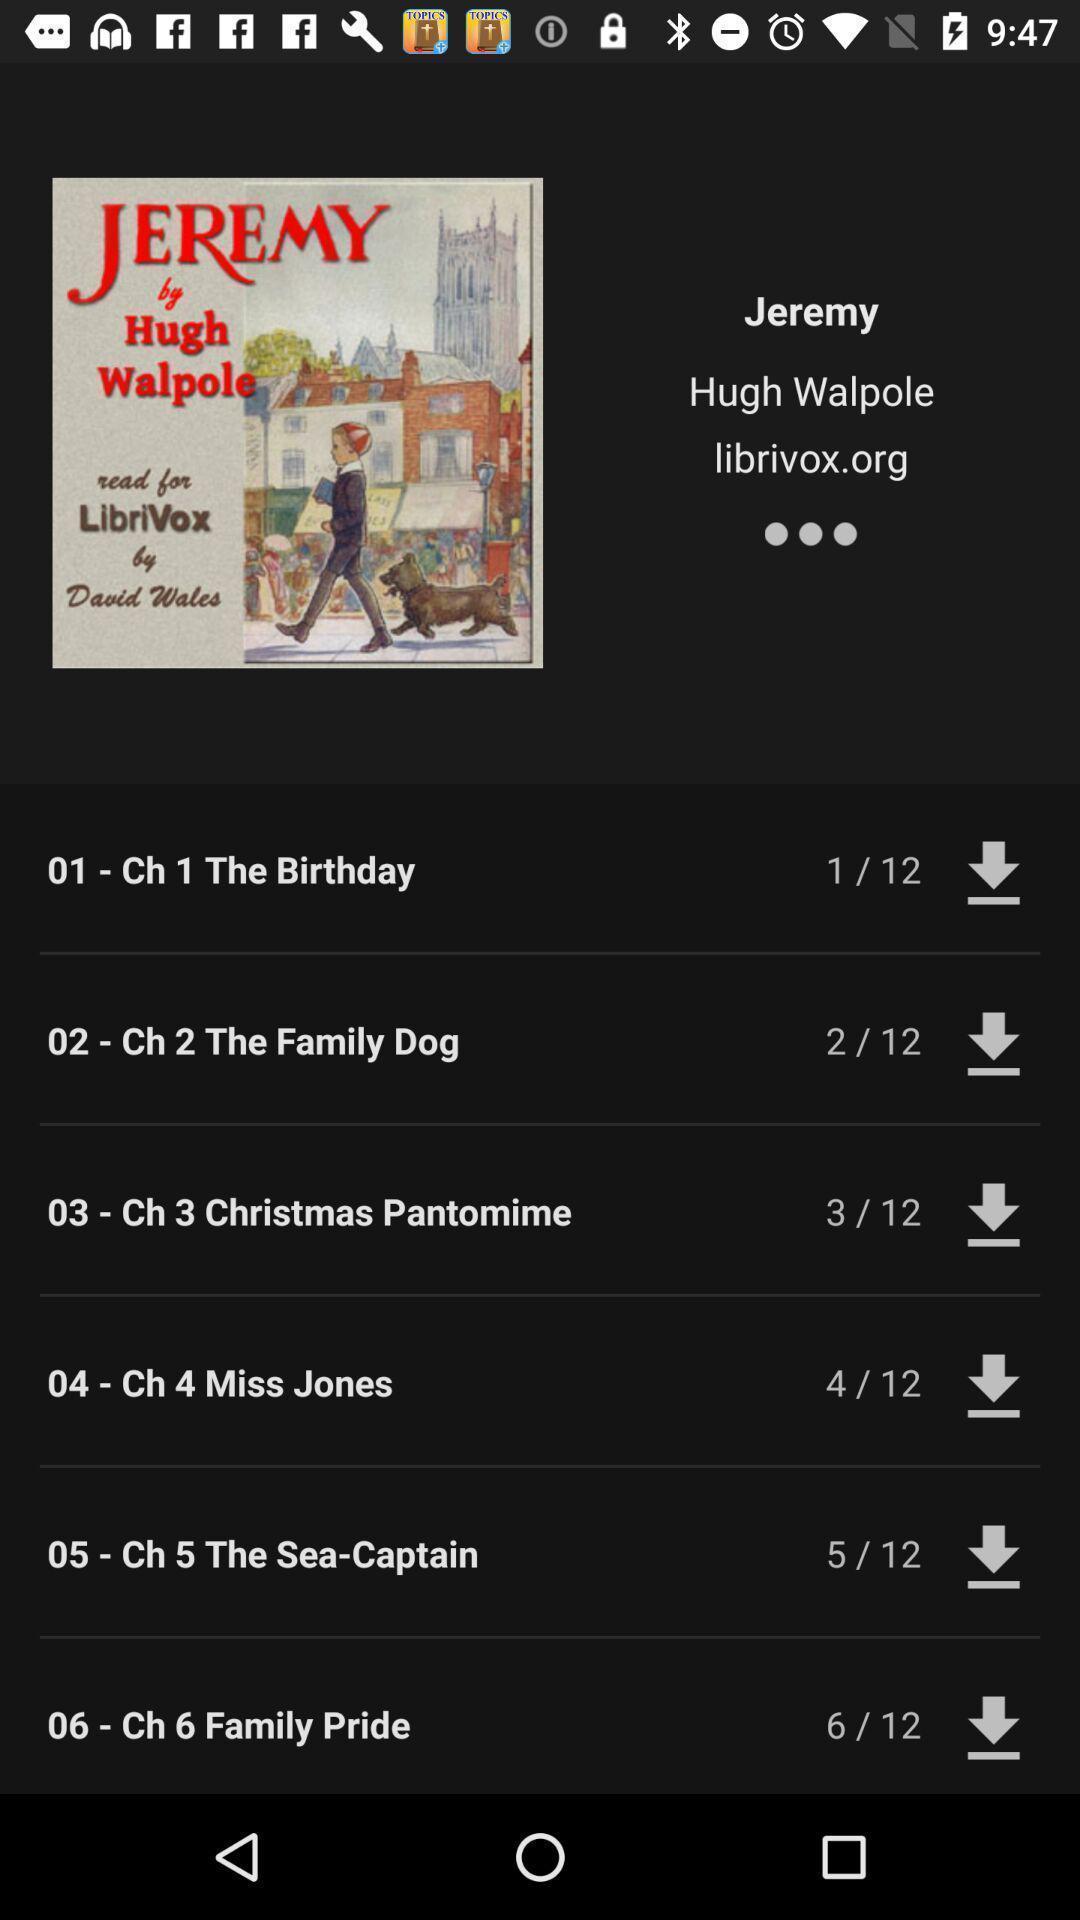Summarize the information in this screenshot. Window displaying list of audio books. 